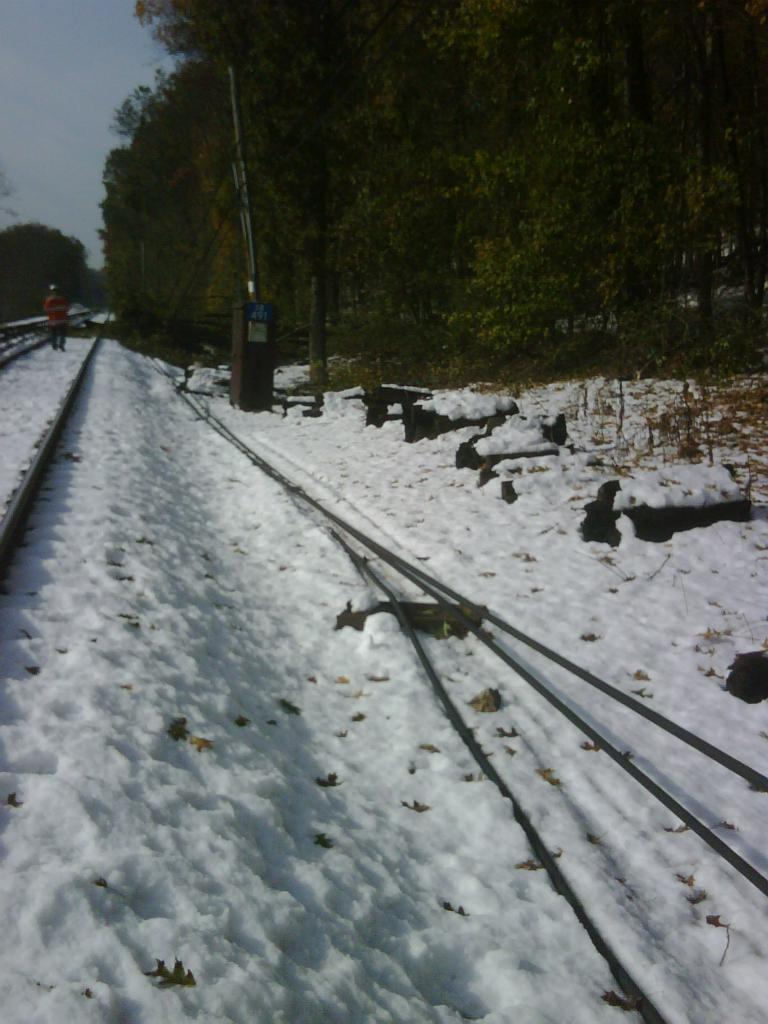What is the main characteristic of the place shown in the image? The place shown in the image is covered with snow. What can be seen on either side of the place? There are trees on either side of the place. What type of plants can be seen growing on the trees in the image? There is no information about plants growing on the trees in the image. Can you see a van parked near the trees in the image? There is no van present in the image. 